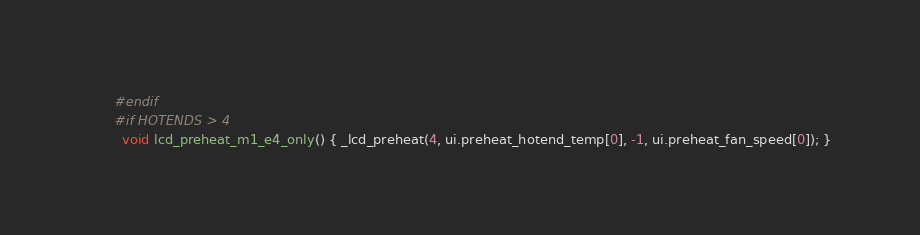Convert code to text. <code><loc_0><loc_0><loc_500><loc_500><_C++_>      #endif
      #if HOTENDS > 4
        void lcd_preheat_m1_e4_only() { _lcd_preheat(4, ui.preheat_hotend_temp[0], -1, ui.preheat_fan_speed[0]); }</code> 